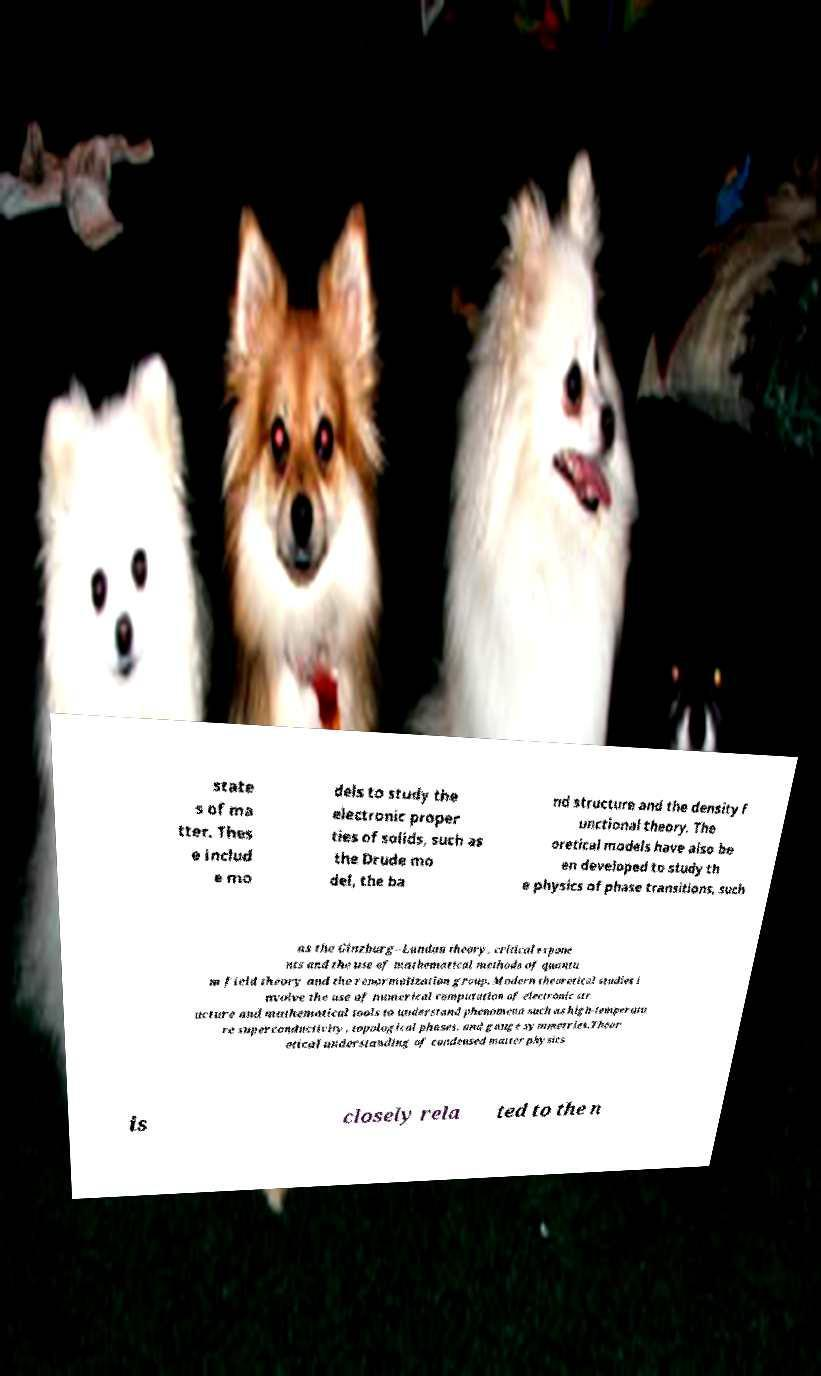Please read and relay the text visible in this image. What does it say? state s of ma tter. Thes e includ e mo dels to study the electronic proper ties of solids, such as the Drude mo del, the ba nd structure and the density f unctional theory. The oretical models have also be en developed to study th e physics of phase transitions, such as the Ginzburg–Landau theory, critical expone nts and the use of mathematical methods of quantu m field theory and the renormalization group. Modern theoretical studies i nvolve the use of numerical computation of electronic str ucture and mathematical tools to understand phenomena such as high-temperatu re superconductivity, topological phases, and gauge symmetries.Theor etical understanding of condensed matter physics is closely rela ted to the n 